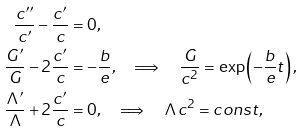Convert formula to latex. <formula><loc_0><loc_0><loc_500><loc_500>\frac { c ^ { \prime \prime } } { c ^ { \prime } } - \frac { c ^ { \prime } } { c } & = 0 , \\ \frac { G ^ { \prime } } { G } - 2 \frac { c ^ { \prime } } { c } & = - \frac { b } { e } , \quad \Longrightarrow \quad \frac { G } { c ^ { 2 } } = \exp \left ( - \frac { b } { e } t \right ) , \\ \frac { \Lambda ^ { \prime } } { \Lambda } + 2 \frac { c ^ { \prime } } { c } & = 0 , \quad \Longrightarrow \quad \Lambda c ^ { 2 } = c o n s t ,</formula> 